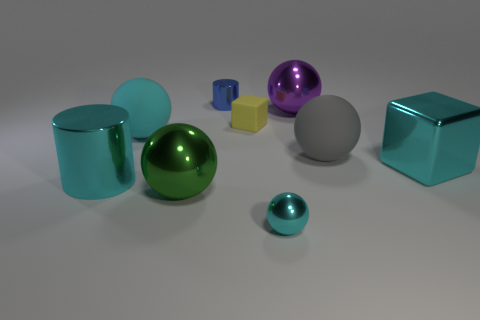Is the material of the tiny thing in front of the small yellow cube the same as the cylinder in front of the small cylinder?
Offer a terse response. Yes. There is a large cyan thing that is left of the large rubber object that is on the left side of the large purple ball; how many big cyan things are in front of it?
Your answer should be very brief. 0. Is the color of the large rubber ball left of the yellow block the same as the matte object that is behind the large cyan sphere?
Your response must be concise. No. Are there any other things of the same color as the small metal cylinder?
Provide a short and direct response. No. There is a shiny cylinder behind the large cyan shiny thing left of the tiny yellow rubber cube; what color is it?
Make the answer very short. Blue. Is there a green metallic object?
Make the answer very short. Yes. What color is the rubber object that is left of the large purple thing and in front of the small yellow object?
Keep it short and to the point. Cyan. Does the cyan sphere that is to the right of the cyan rubber object have the same size as the metal cylinder behind the big block?
Your answer should be compact. Yes. How many other things are the same size as the cyan metallic sphere?
Offer a terse response. 2. There is a cyan sphere on the left side of the small blue cylinder; what number of big metallic balls are behind it?
Your answer should be compact. 1. 